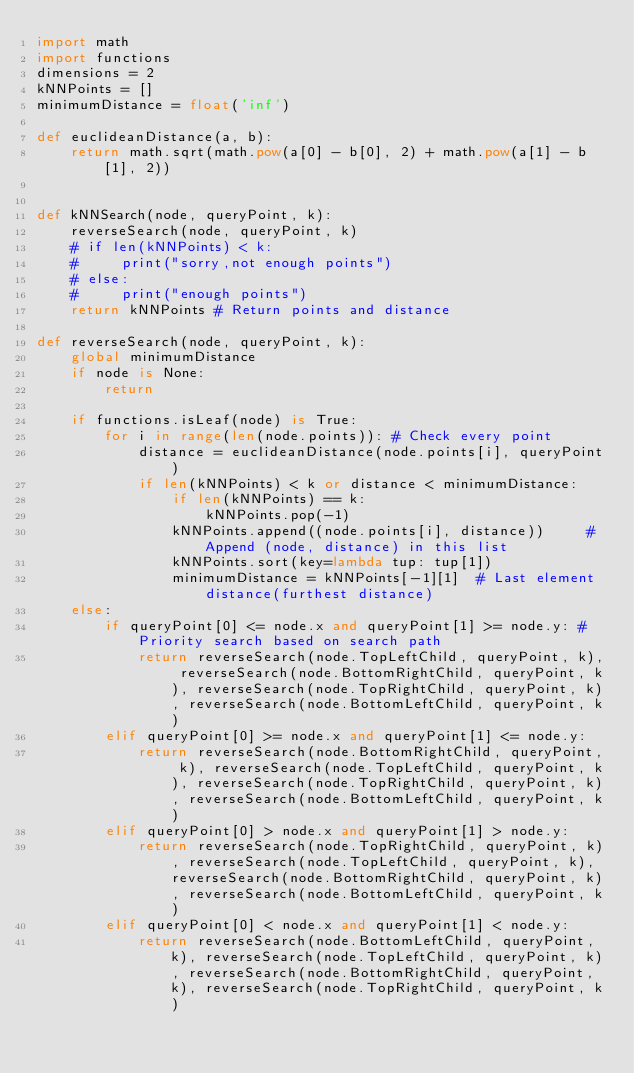<code> <loc_0><loc_0><loc_500><loc_500><_Python_>import math
import functions
dimensions = 2
kNNPoints = []
minimumDistance = float('inf')

def euclideanDistance(a, b):
    return math.sqrt(math.pow(a[0] - b[0], 2) + math.pow(a[1] - b[1], 2))


def kNNSearch(node, queryPoint, k):
    reverseSearch(node, queryPoint, k) 
    # if len(kNNPoints) < k:
    #     print("sorry,not enough points")
    # else:
    #     print("enough points")
    return kNNPoints # Return points and distance

def reverseSearch(node, queryPoint, k):
    global minimumDistance
    if node is None:
        return

    if functions.isLeaf(node) is True:
        for i in range(len(node.points)): # Check every point
            distance = euclideanDistance(node.points[i], queryPoint)
            if len(kNNPoints) < k or distance < minimumDistance:
                if len(kNNPoints) == k:
                    kNNPoints.pop(-1)
                kNNPoints.append((node.points[i], distance))     # Append (node, distance) in this list
                kNNPoints.sort(key=lambda tup: tup[1])
                minimumDistance = kNNPoints[-1][1]  # Last element distance(furthest distance)
    else:
        if queryPoint[0] <= node.x and queryPoint[1] >= node.y: # Priority search based on search path
            return reverseSearch(node.TopLeftChild, queryPoint, k), reverseSearch(node.BottomRightChild, queryPoint, k), reverseSearch(node.TopRightChild, queryPoint, k), reverseSearch(node.BottomLeftChild, queryPoint, k)
        elif queryPoint[0] >= node.x and queryPoint[1] <= node.y:
            return reverseSearch(node.BottomRightChild, queryPoint, k), reverseSearch(node.TopLeftChild, queryPoint, k), reverseSearch(node.TopRightChild, queryPoint, k), reverseSearch(node.BottomLeftChild, queryPoint, k)
        elif queryPoint[0] > node.x and queryPoint[1] > node.y:
            return reverseSearch(node.TopRightChild, queryPoint, k), reverseSearch(node.TopLeftChild, queryPoint, k), reverseSearch(node.BottomRightChild, queryPoint, k), reverseSearch(node.BottomLeftChild, queryPoint, k)
        elif queryPoint[0] < node.x and queryPoint[1] < node.y:
            return reverseSearch(node.BottomLeftChild, queryPoint, k), reverseSearch(node.TopLeftChild, queryPoint, k), reverseSearch(node.BottomRightChild, queryPoint, k), reverseSearch(node.TopRightChild, queryPoint, k)</code> 